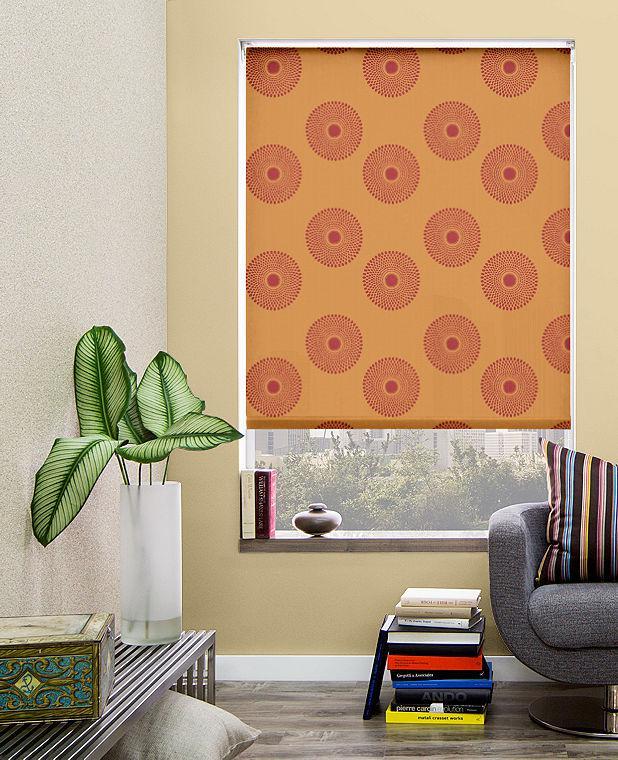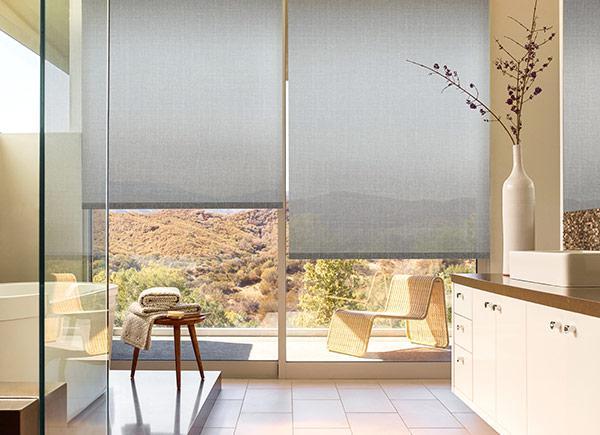The first image is the image on the left, the second image is the image on the right. Assess this claim about the two images: "The left image shows a chair to the right of a window with a pattern-printed window shade.". Correct or not? Answer yes or no. Yes. 